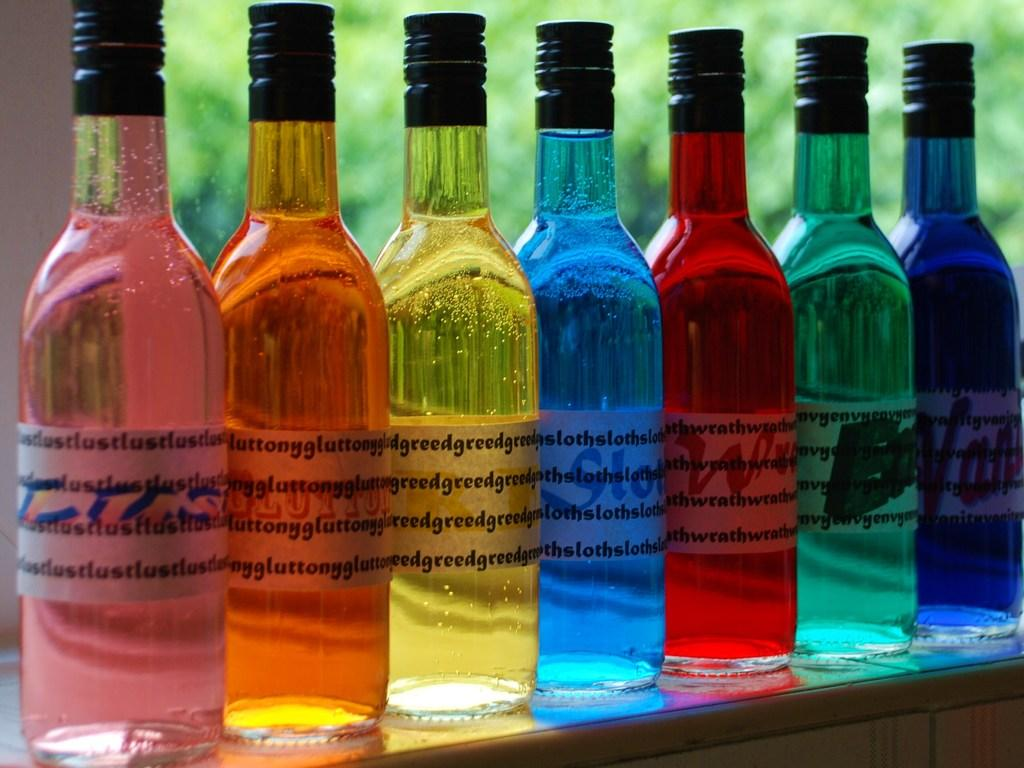Provide a one-sentence caption for the provided image. The yellow bottle is greed and the pink bottle is lust. 